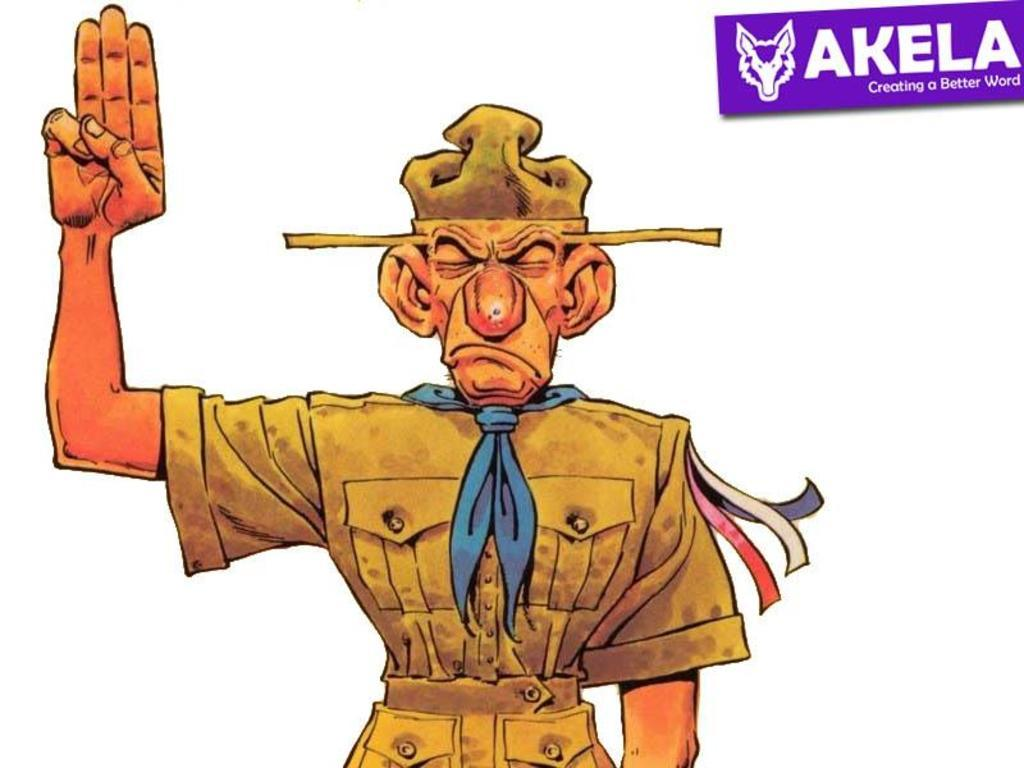What type of picture is shown in the image? The image is an animated picture. Can you describe any characters or figures in the animated picture? There is a man in the animated picture. Is there any branding or identification in the animated picture? Yes, there is a logo in the animated picture. How many chickens are on the roof in the animated picture? There are no chickens or roofs present in the animated picture; it features a man and a logo. 